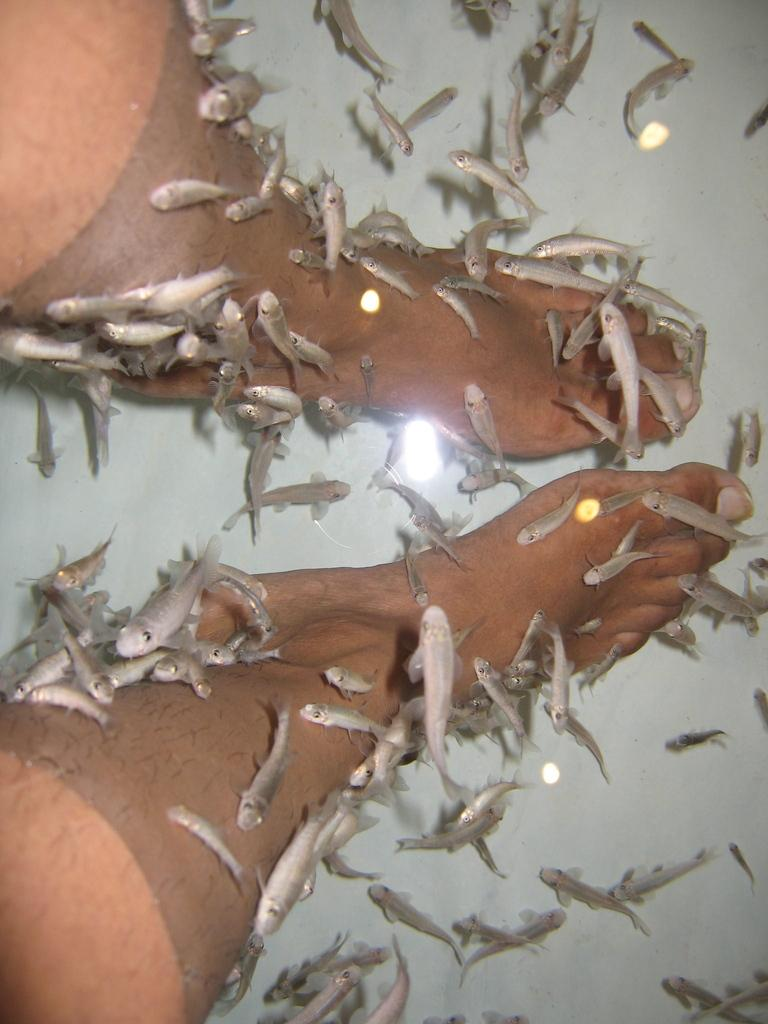What is the main object in the image? There is a fish tank in the image. What can be found inside the fish tank? There are fishes in the fish tank. Can you see any part of a person in the image? Yes, the legs of a person are visible in the image. What is the appearance of the water in the fish tank? There is a reflection of light in the water. What type of crime is being committed by the finger in the image? There is no finger or crime present in the image. 